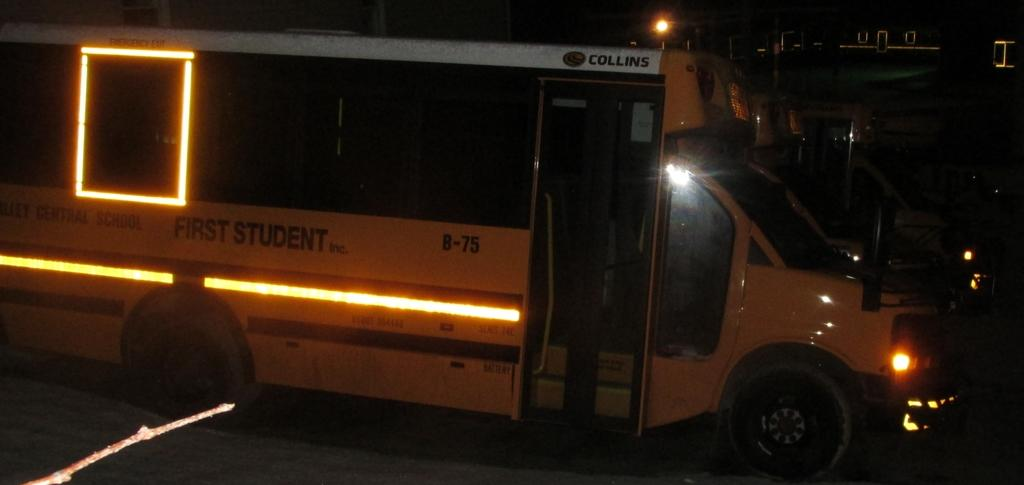What type of vehicle is in the picture? There is a mini bus in the picture. What kind of mini bus is it? The mini bus appears to be a school bus. What can be seen in the picture besides the mini bus? There are lights visible in the picture. What is visible in the background of the picture? There is a building in the background of the picture. How would you describe the lighting conditions in the picture? The background of the picture is dark. Can you see a band playing in the picture? There is no band present in the image. 